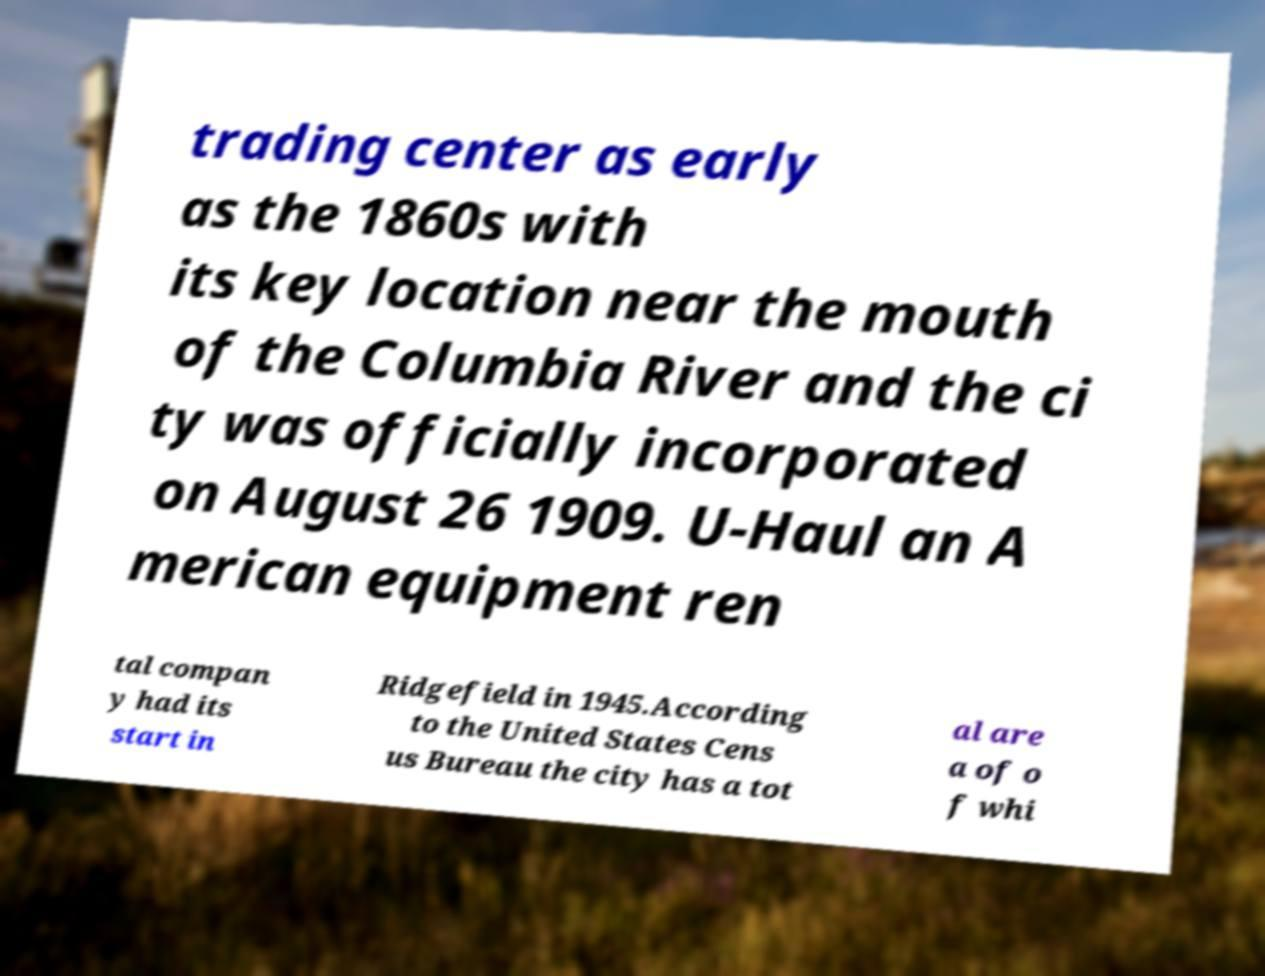Can you accurately transcribe the text from the provided image for me? trading center as early as the 1860s with its key location near the mouth of the Columbia River and the ci ty was officially incorporated on August 26 1909. U-Haul an A merican equipment ren tal compan y had its start in Ridgefield in 1945.According to the United States Cens us Bureau the city has a tot al are a of o f whi 